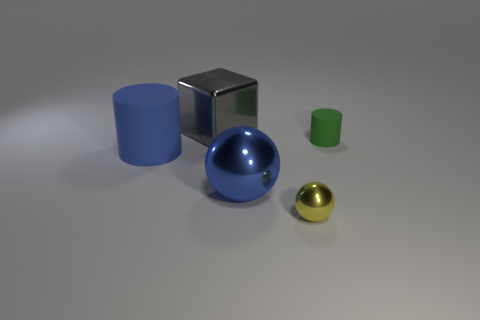There is a tiny object that is behind the large blue thing on the right side of the large object behind the blue cylinder; what color is it? The small object situated behind the large blue sphere on the right, and further behind the blue cylinder, displays a green color. It is easily distinguishable by its more muted hue compared to the other vibrant objects in the scene. 